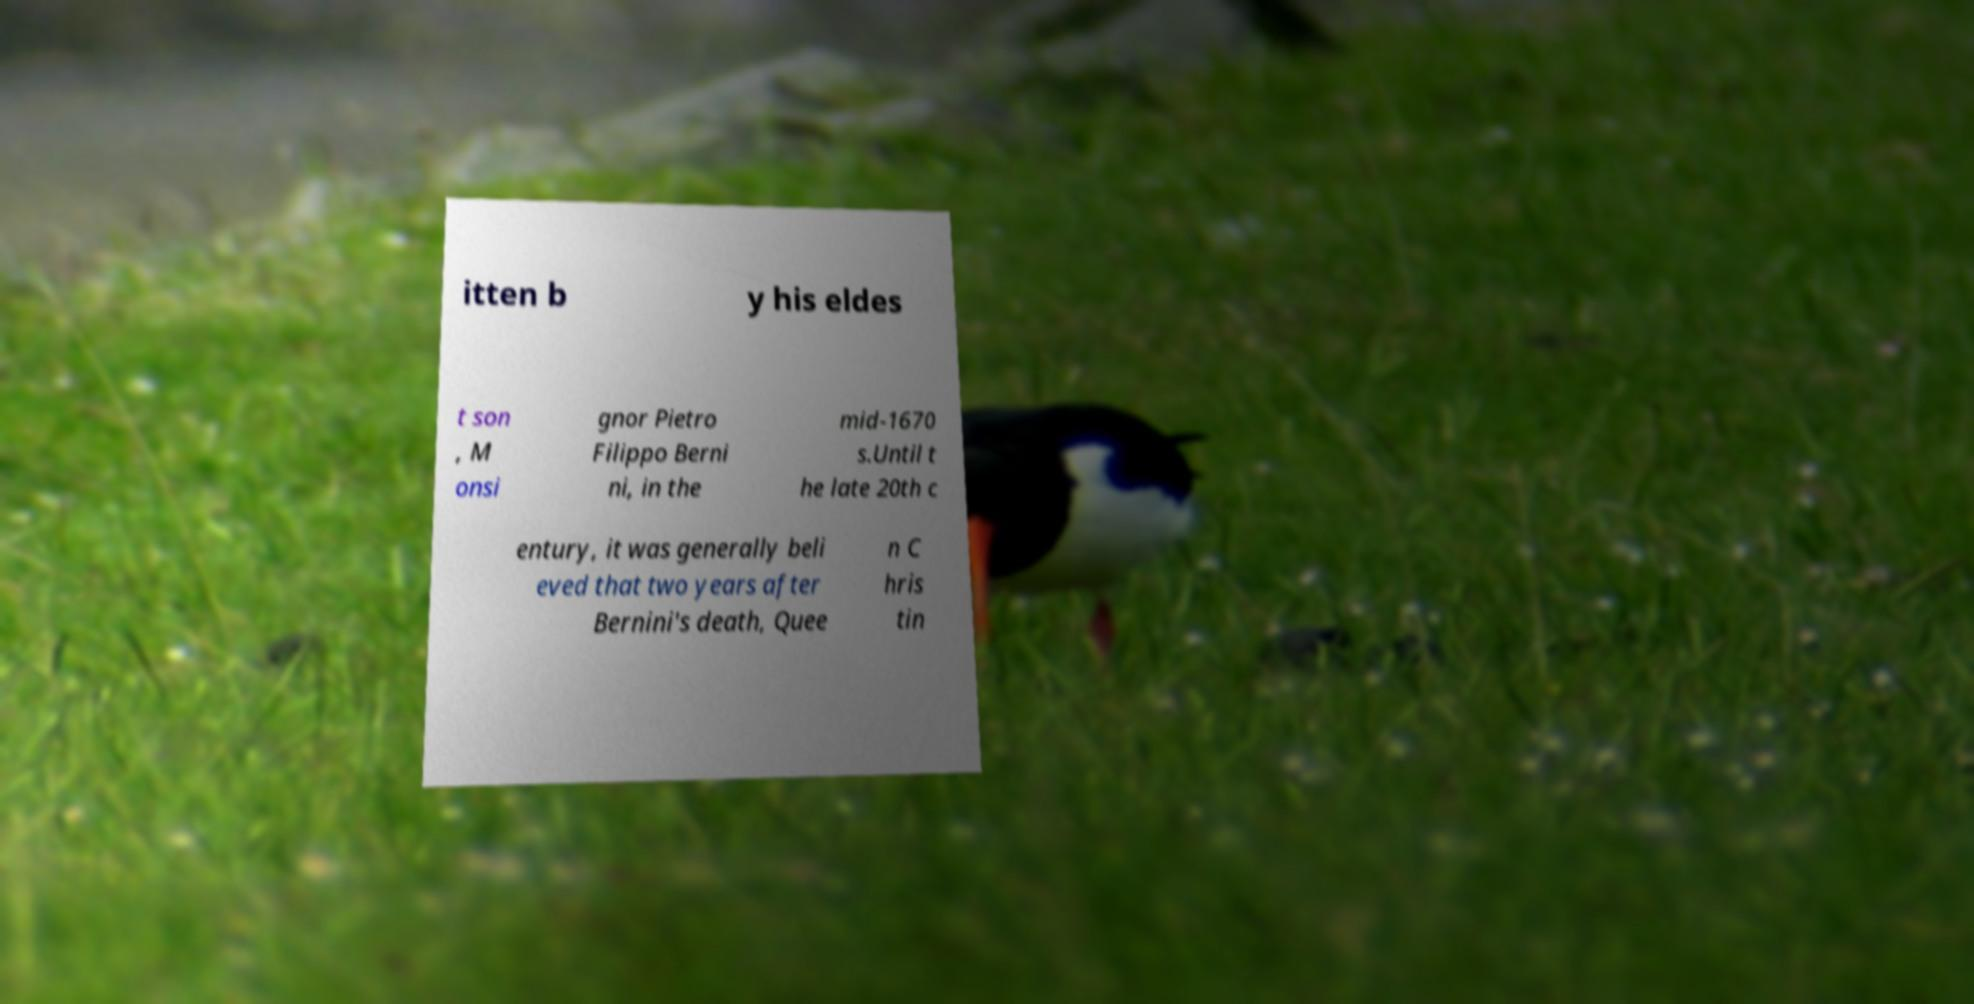Could you assist in decoding the text presented in this image and type it out clearly? itten b y his eldes t son , M onsi gnor Pietro Filippo Berni ni, in the mid-1670 s.Until t he late 20th c entury, it was generally beli eved that two years after Bernini's death, Quee n C hris tin 